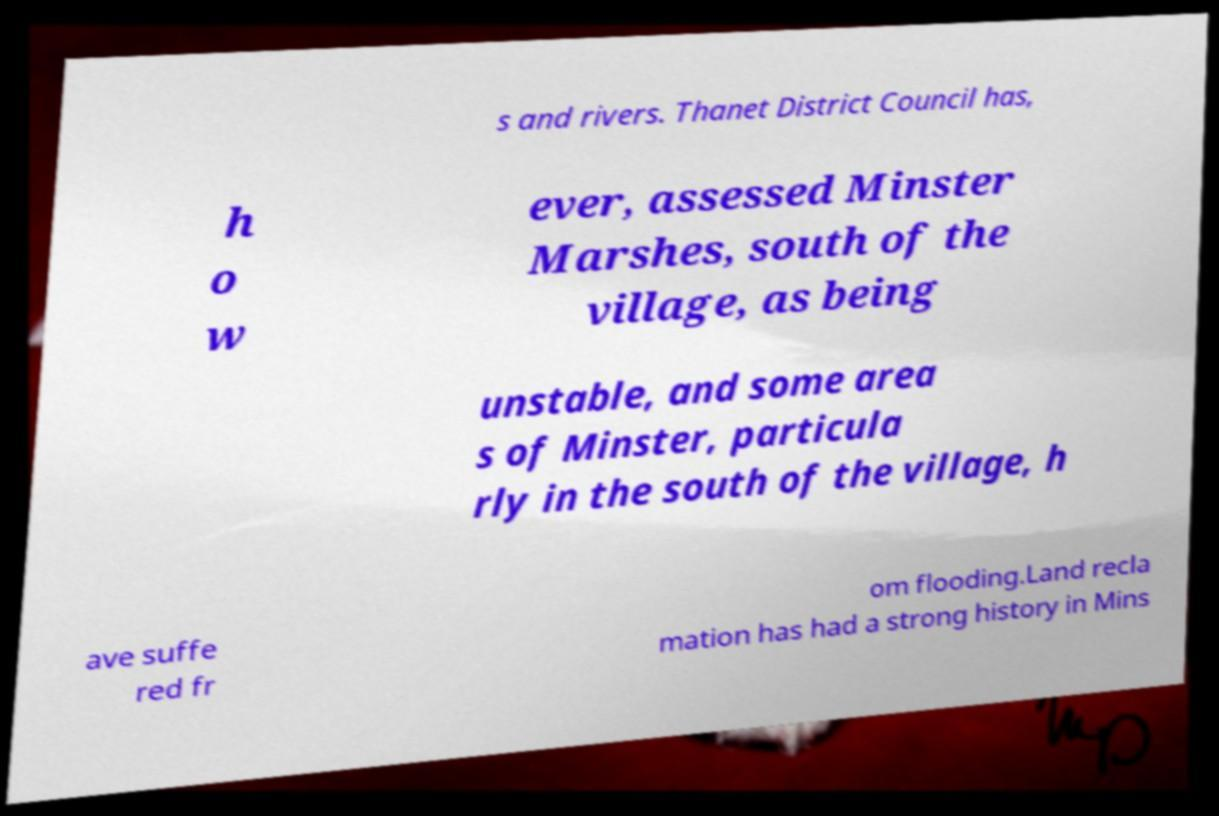For documentation purposes, I need the text within this image transcribed. Could you provide that? s and rivers. Thanet District Council has, h o w ever, assessed Minster Marshes, south of the village, as being unstable, and some area s of Minster, particula rly in the south of the village, h ave suffe red fr om flooding.Land recla mation has had a strong history in Mins 